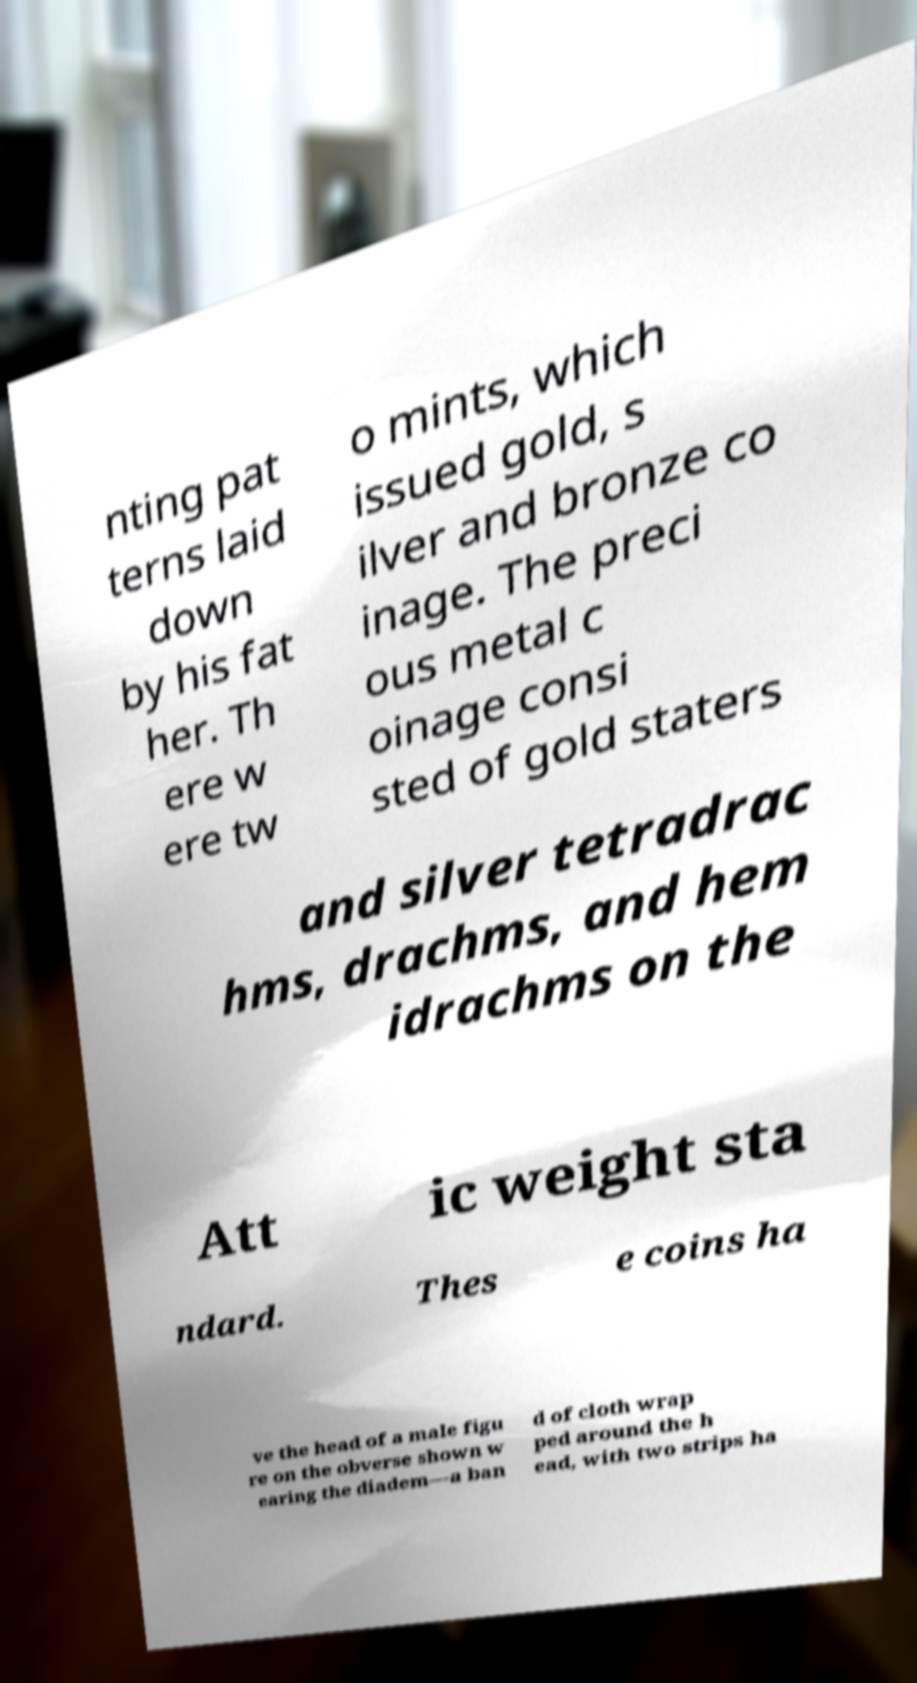Please identify and transcribe the text found in this image. nting pat terns laid down by his fat her. Th ere w ere tw o mints, which issued gold, s ilver and bronze co inage. The preci ous metal c oinage consi sted of gold staters and silver tetradrac hms, drachms, and hem idrachms on the Att ic weight sta ndard. Thes e coins ha ve the head of a male figu re on the obverse shown w earing the diadem—a ban d of cloth wrap ped around the h ead, with two strips ha 